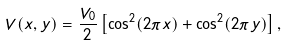<formula> <loc_0><loc_0><loc_500><loc_500>V ( x , y ) = \frac { V _ { 0 } } { 2 } \left [ \cos ^ { 2 } ( 2 \pi x ) + \cos ^ { 2 } ( 2 \pi y ) \right ] ,</formula> 